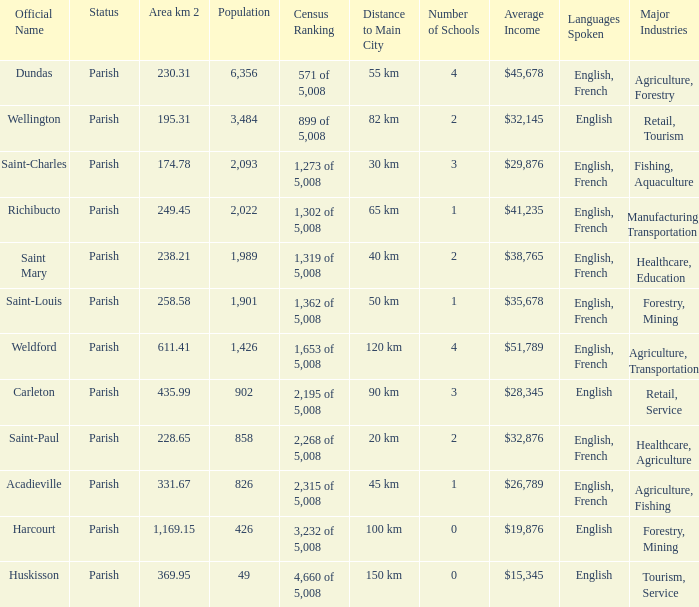For Saint-Paul parish, if it has an area of over 228.65 kilometers how many people live there? 0.0. 